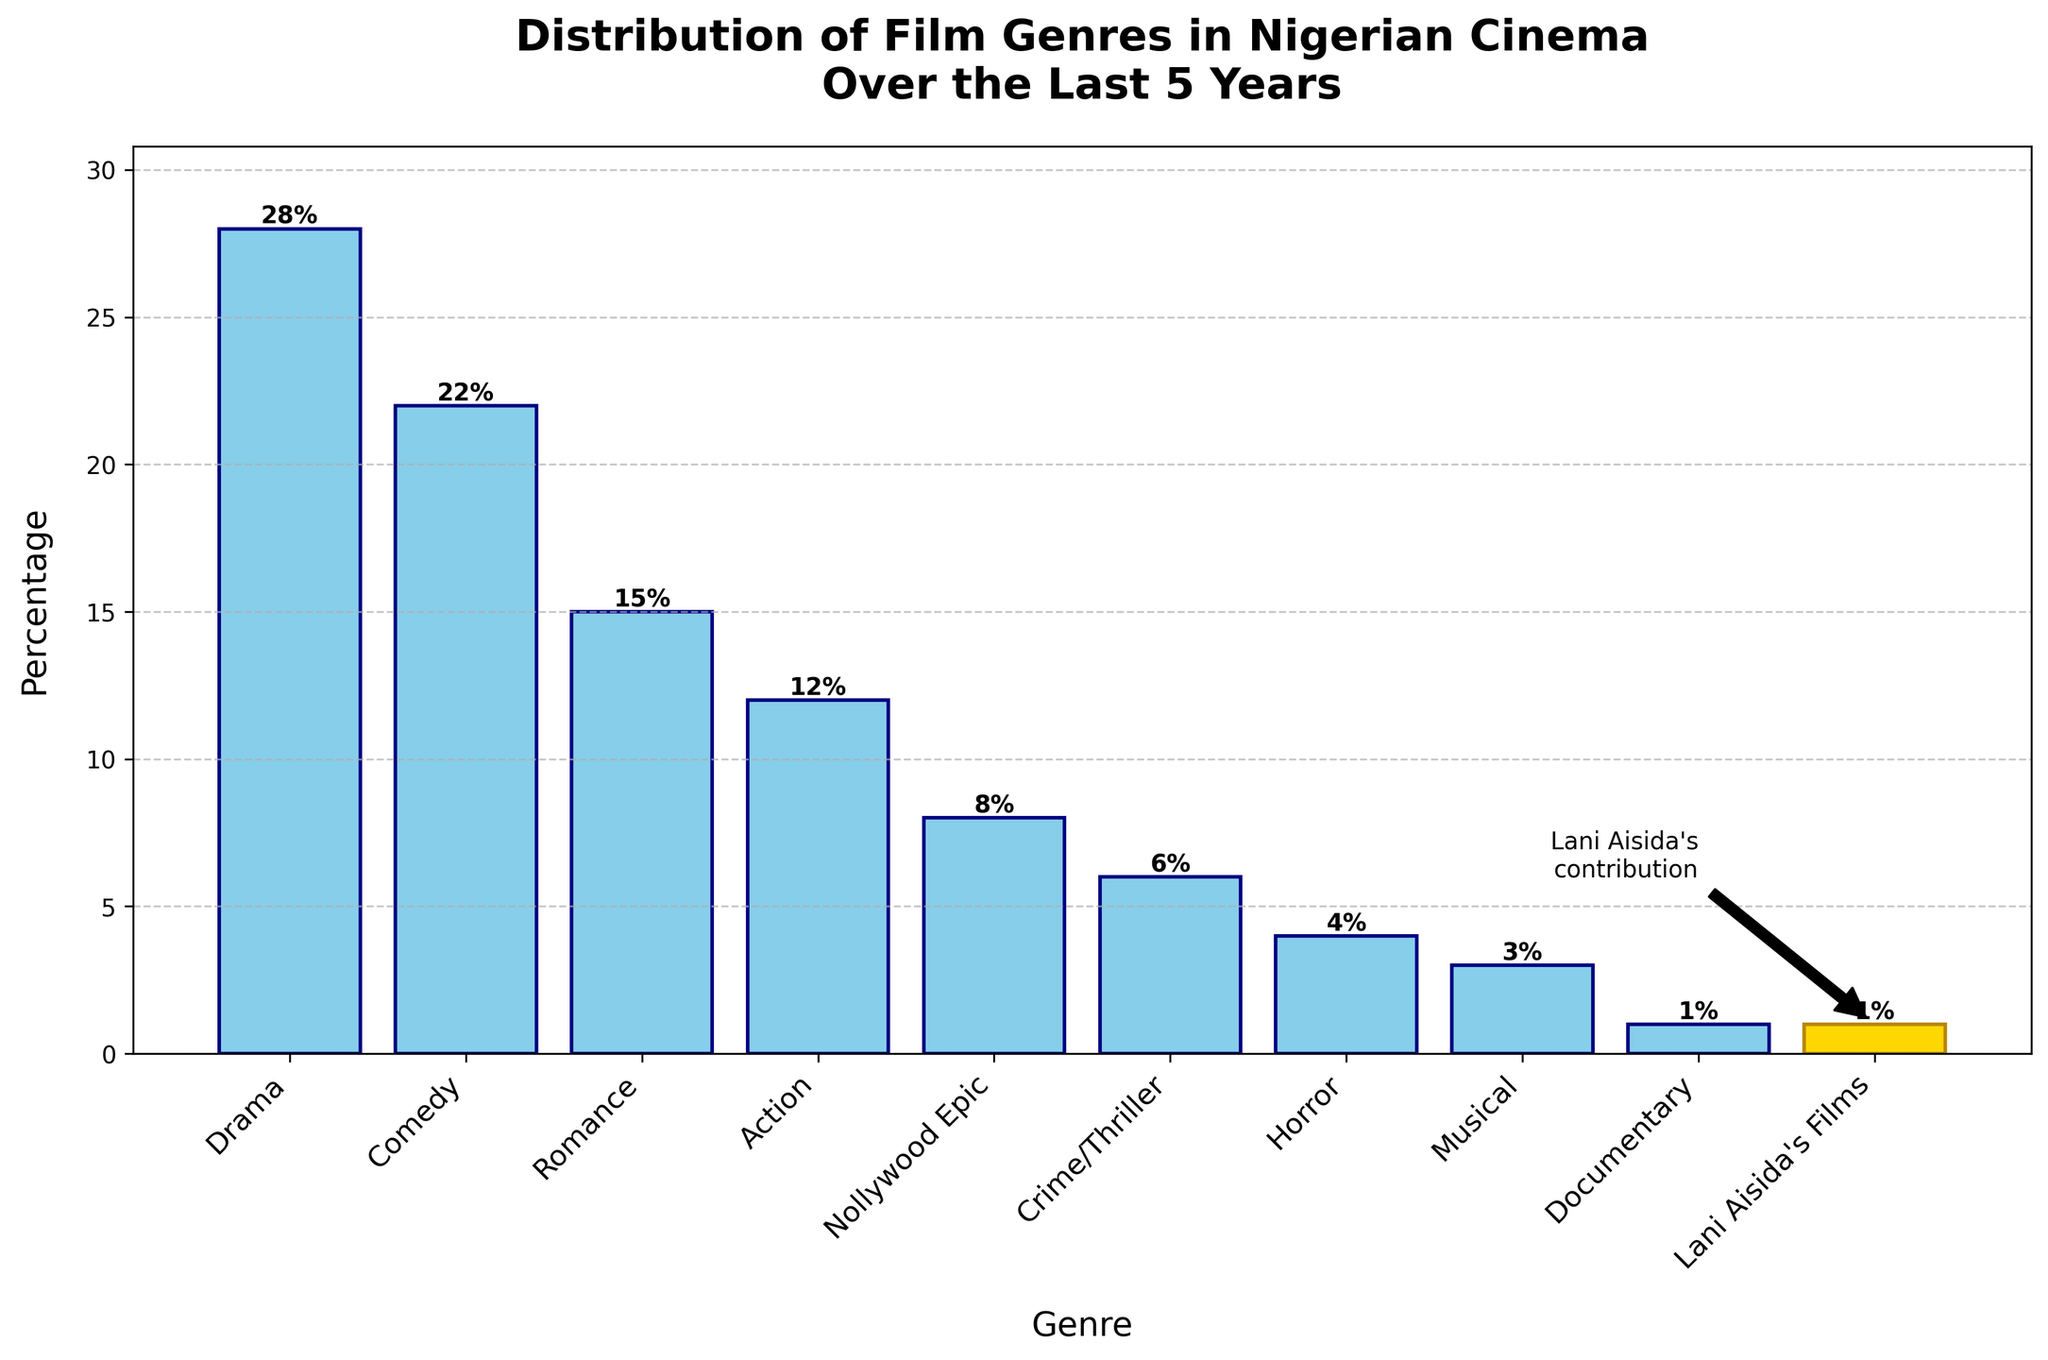Which genre has the highest percentage in Nigerian cinema over the last 5 years? Look at the height of the bars. The tallest bar represents the genre with the highest percentage. In this case, the Drama genre has the tallest bar.
Answer: Drama What is the total percentage of Drama and Comedy films combined? Add the percentages of Drama (28%) and Comedy (22%). 28% + 22% equals 50%.
Answer: 50% Which genre has a lower percentage: Action or Crime/Thriller? Compare the heights of the bars representing Action and Crime/Thriller. The Action bar (12%) is taller than the Crime/Thriller bar (6%).
Answer: Crime/Thriller How much higher is the percentage of Romance films compared to Horror films? Subtract the percentage of Horror films (4%) from the percentage of Romance films (15%). 15% - 4% equals 11%.
Answer: 11% What is the average percentage of all listed film genres? Sum up all percentages (28 + 22 + 15 + 12 + 8 + 6 + 4 + 3 + 1 + 1) which equals 100. Divide by 10 genres. 100 / 10 equals 10%.
Answer: 10% What percentage of the total film genres is represented by Nollywood Epic and Musical combined? Add the percentages of Nollywood Epic (8%) and Musical (3%). 8% + 3% equals 11%.
Answer: 11% Which genre is visually highlighted in the bar chart? Identify the bar with a different color or an additional annotation. The bar for "Lani Aisida's Films" is highlighted.
Answer: Lani Aisida's Films What genre represents the smallest percentage of films? Find the shortest bar in the chart. The bar for both "Documentary" and "Lani Aisida's Films" is the shortest at 1%.
Answer: Documentary and Lani Aisida's Films How much less is the percentage of Crime/Thriller films compared to Comedy films? Subtract the percentage of Crime/Thriller (6%) from Comedy (22%). 22% - 6% equals 16%.
Answer: 16% Is the percentage of Action films closer to Drama or Romance films? Compare the differences between Action (12%) and Drama (28%), and Action and Romance (15%). 28 - 12 = 16 and 15 - 12 = 3. The difference is smaller between Action and Romance.
Answer: Romance 